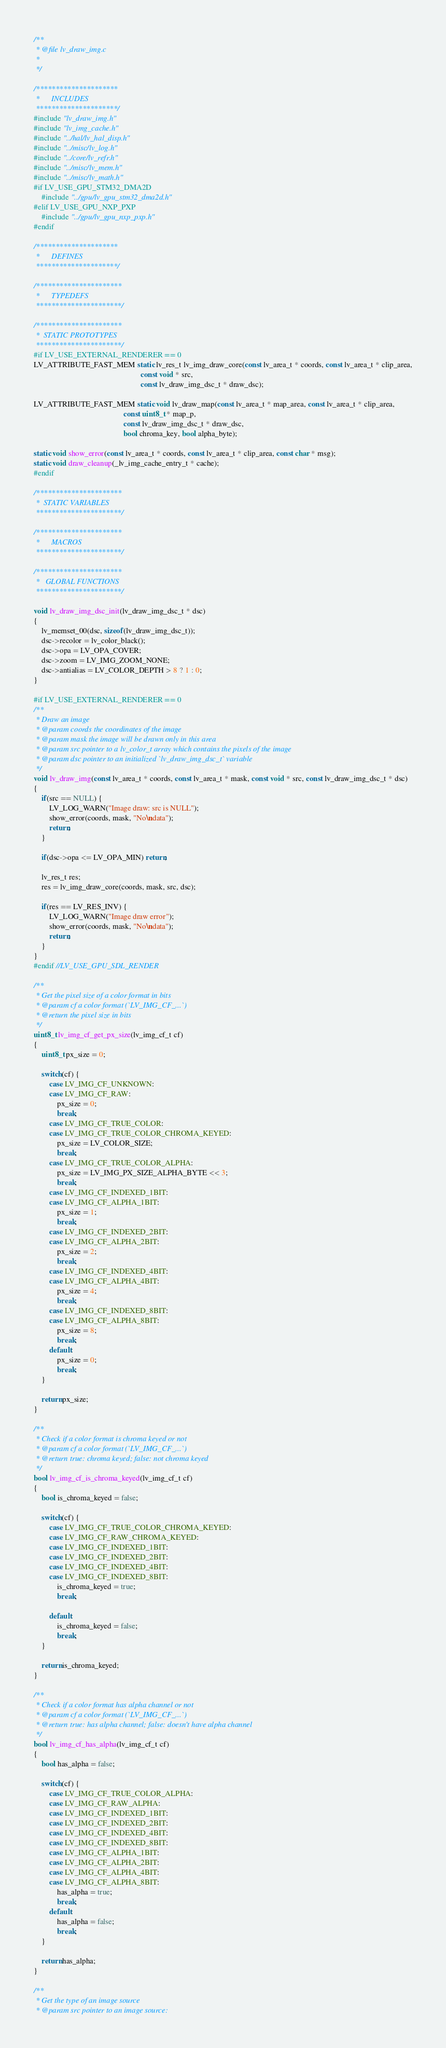<code> <loc_0><loc_0><loc_500><loc_500><_C_>/**
 * @file lv_draw_img.c
 *
 */

/*********************
 *      INCLUDES
 *********************/
#include "lv_draw_img.h"
#include "lv_img_cache.h"
#include "../hal/lv_hal_disp.h"
#include "../misc/lv_log.h"
#include "../core/lv_refr.h"
#include "../misc/lv_mem.h"
#include "../misc/lv_math.h"
#if LV_USE_GPU_STM32_DMA2D
    #include "../gpu/lv_gpu_stm32_dma2d.h"
#elif LV_USE_GPU_NXP_PXP
    #include "../gpu/lv_gpu_nxp_pxp.h"
#endif

/*********************
 *      DEFINES
 *********************/

/**********************
 *      TYPEDEFS
 **********************/

/**********************
 *  STATIC PROTOTYPES
 **********************/
#if LV_USE_EXTERNAL_RENDERER == 0
LV_ATTRIBUTE_FAST_MEM static lv_res_t lv_img_draw_core(const lv_area_t * coords, const lv_area_t * clip_area,
                                                       const void * src,
                                                       const lv_draw_img_dsc_t * draw_dsc);

LV_ATTRIBUTE_FAST_MEM static void lv_draw_map(const lv_area_t * map_area, const lv_area_t * clip_area,
                                              const uint8_t * map_p,
                                              const lv_draw_img_dsc_t * draw_dsc,
                                              bool chroma_key, bool alpha_byte);

static void show_error(const lv_area_t * coords, const lv_area_t * clip_area, const char * msg);
static void draw_cleanup(_lv_img_cache_entry_t * cache);
#endif

/**********************
 *  STATIC VARIABLES
 **********************/

/**********************
 *      MACROS
 **********************/

/**********************
 *   GLOBAL FUNCTIONS
 **********************/

void lv_draw_img_dsc_init(lv_draw_img_dsc_t * dsc)
{
    lv_memset_00(dsc, sizeof(lv_draw_img_dsc_t));
    dsc->recolor = lv_color_black();
    dsc->opa = LV_OPA_COVER;
    dsc->zoom = LV_IMG_ZOOM_NONE;
    dsc->antialias = LV_COLOR_DEPTH > 8 ? 1 : 0;
}

#if LV_USE_EXTERNAL_RENDERER == 0
/**
 * Draw an image
 * @param coords the coordinates of the image
 * @param mask the image will be drawn only in this area
 * @param src pointer to a lv_color_t array which contains the pixels of the image
 * @param dsc pointer to an initialized `lv_draw_img_dsc_t` variable
 */
void lv_draw_img(const lv_area_t * coords, const lv_area_t * mask, const void * src, const lv_draw_img_dsc_t * dsc)
{
    if(src == NULL) {
        LV_LOG_WARN("Image draw: src is NULL");
        show_error(coords, mask, "No\ndata");
        return;
    }

    if(dsc->opa <= LV_OPA_MIN) return;

    lv_res_t res;
    res = lv_img_draw_core(coords, mask, src, dsc);

    if(res == LV_RES_INV) {
        LV_LOG_WARN("Image draw error");
        show_error(coords, mask, "No\ndata");
        return;
    }
}
#endif //LV_USE_GPU_SDL_RENDER

/**
 * Get the pixel size of a color format in bits
 * @param cf a color format (`LV_IMG_CF_...`)
 * @return the pixel size in bits
 */
uint8_t lv_img_cf_get_px_size(lv_img_cf_t cf)
{
    uint8_t px_size = 0;

    switch(cf) {
        case LV_IMG_CF_UNKNOWN:
        case LV_IMG_CF_RAW:
            px_size = 0;
            break;
        case LV_IMG_CF_TRUE_COLOR:
        case LV_IMG_CF_TRUE_COLOR_CHROMA_KEYED:
            px_size = LV_COLOR_SIZE;
            break;
        case LV_IMG_CF_TRUE_COLOR_ALPHA:
            px_size = LV_IMG_PX_SIZE_ALPHA_BYTE << 3;
            break;
        case LV_IMG_CF_INDEXED_1BIT:
        case LV_IMG_CF_ALPHA_1BIT:
            px_size = 1;
            break;
        case LV_IMG_CF_INDEXED_2BIT:
        case LV_IMG_CF_ALPHA_2BIT:
            px_size = 2;
            break;
        case LV_IMG_CF_INDEXED_4BIT:
        case LV_IMG_CF_ALPHA_4BIT:
            px_size = 4;
            break;
        case LV_IMG_CF_INDEXED_8BIT:
        case LV_IMG_CF_ALPHA_8BIT:
            px_size = 8;
            break;
        default:
            px_size = 0;
            break;
    }

    return px_size;
}

/**
 * Check if a color format is chroma keyed or not
 * @param cf a color format (`LV_IMG_CF_...`)
 * @return true: chroma keyed; false: not chroma keyed
 */
bool lv_img_cf_is_chroma_keyed(lv_img_cf_t cf)
{
    bool is_chroma_keyed = false;

    switch(cf) {
        case LV_IMG_CF_TRUE_COLOR_CHROMA_KEYED:
        case LV_IMG_CF_RAW_CHROMA_KEYED:
        case LV_IMG_CF_INDEXED_1BIT:
        case LV_IMG_CF_INDEXED_2BIT:
        case LV_IMG_CF_INDEXED_4BIT:
        case LV_IMG_CF_INDEXED_8BIT:
            is_chroma_keyed = true;
            break;

        default:
            is_chroma_keyed = false;
            break;
    }

    return is_chroma_keyed;
}

/**
 * Check if a color format has alpha channel or not
 * @param cf a color format (`LV_IMG_CF_...`)
 * @return true: has alpha channel; false: doesn't have alpha channel
 */
bool lv_img_cf_has_alpha(lv_img_cf_t cf)
{
    bool has_alpha = false;

    switch(cf) {
        case LV_IMG_CF_TRUE_COLOR_ALPHA:
        case LV_IMG_CF_RAW_ALPHA:
        case LV_IMG_CF_INDEXED_1BIT:
        case LV_IMG_CF_INDEXED_2BIT:
        case LV_IMG_CF_INDEXED_4BIT:
        case LV_IMG_CF_INDEXED_8BIT:
        case LV_IMG_CF_ALPHA_1BIT:
        case LV_IMG_CF_ALPHA_2BIT:
        case LV_IMG_CF_ALPHA_4BIT:
        case LV_IMG_CF_ALPHA_8BIT:
            has_alpha = true;
            break;
        default:
            has_alpha = false;
            break;
    }

    return has_alpha;
}

/**
 * Get the type of an image source
 * @param src pointer to an image source:</code> 